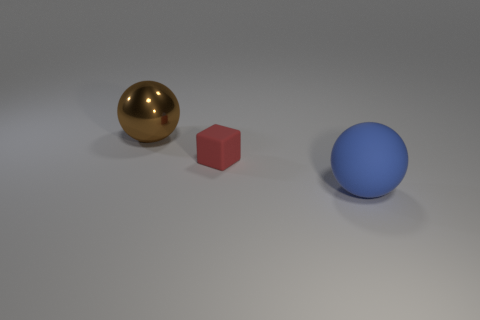Subtract 1 blocks. How many blocks are left? 0 Subtract all brown spheres. How many spheres are left? 1 Add 3 purple matte cylinders. How many objects exist? 6 Add 2 small cubes. How many small cubes are left? 3 Add 2 tiny shiny spheres. How many tiny shiny spheres exist? 2 Subtract 0 purple cylinders. How many objects are left? 3 Subtract all spheres. How many objects are left? 1 Subtract all tiny brown cubes. Subtract all big blue objects. How many objects are left? 2 